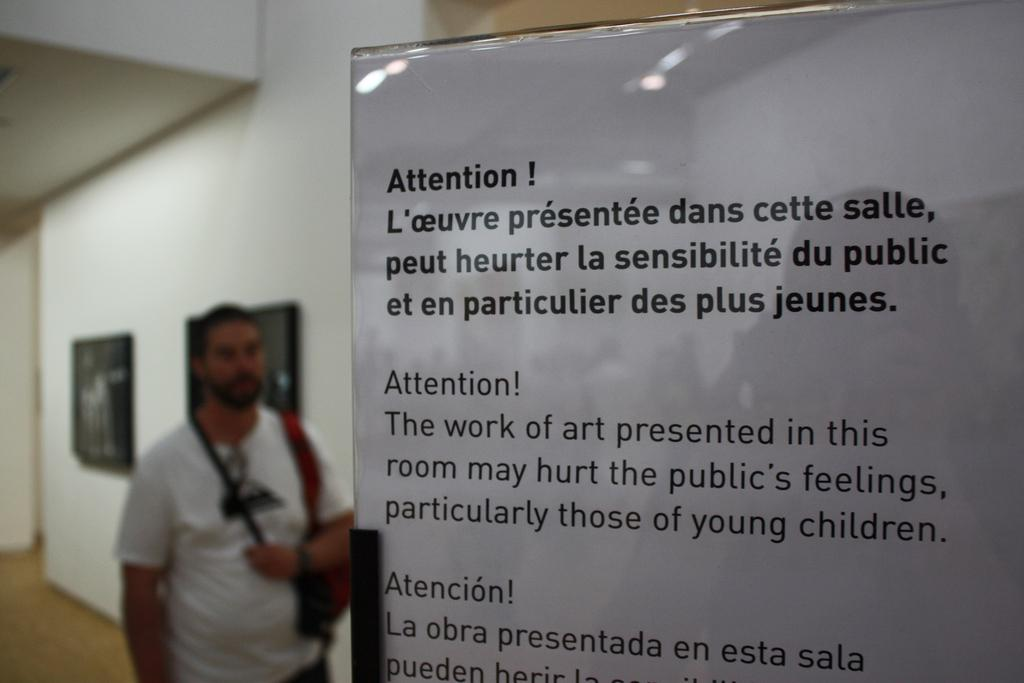What is the main object in the image? There is a board in the image. What is the man on the floor doing? The man on the floor is not performing any visible actions in the image. What can be seen on the wall in the background? There are frames on the wall in the background of the image. What type of pets are sitting on the committee in the image? There is no committee or pets present in the image. What type of airplane can be seen flying in the background of the image? There is no airplane visible in the image; it only features a board, a man on the floor, and frames on the wall in the background. 